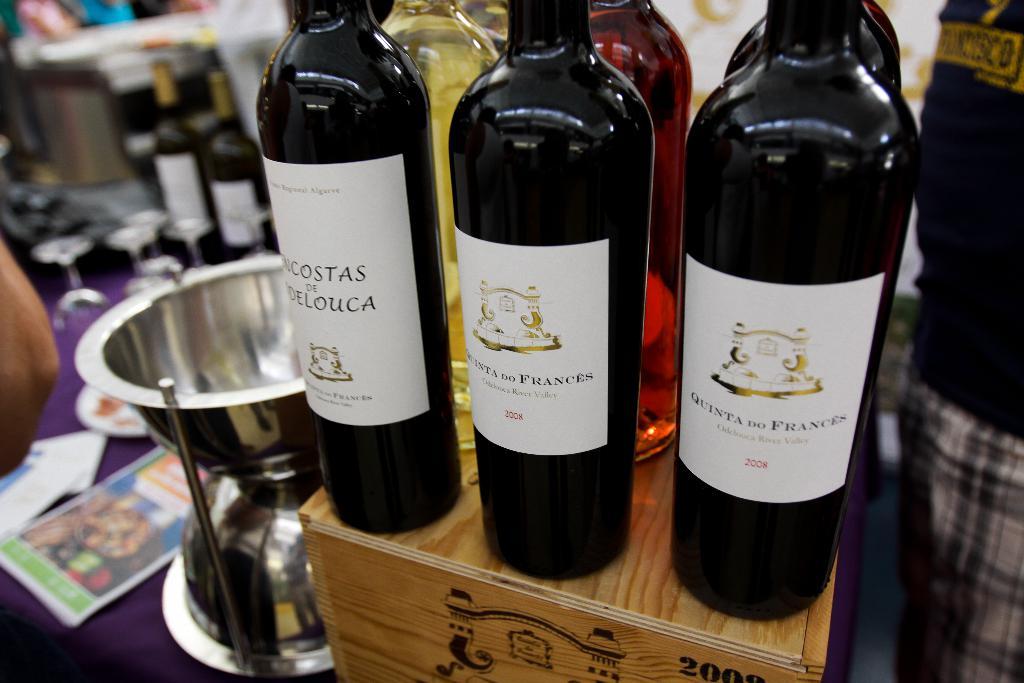What year is the right bottle from?
Ensure brevity in your answer.  2008. What is the date on the wood in the bottom right?
Provide a succinct answer. Unanswerable. 